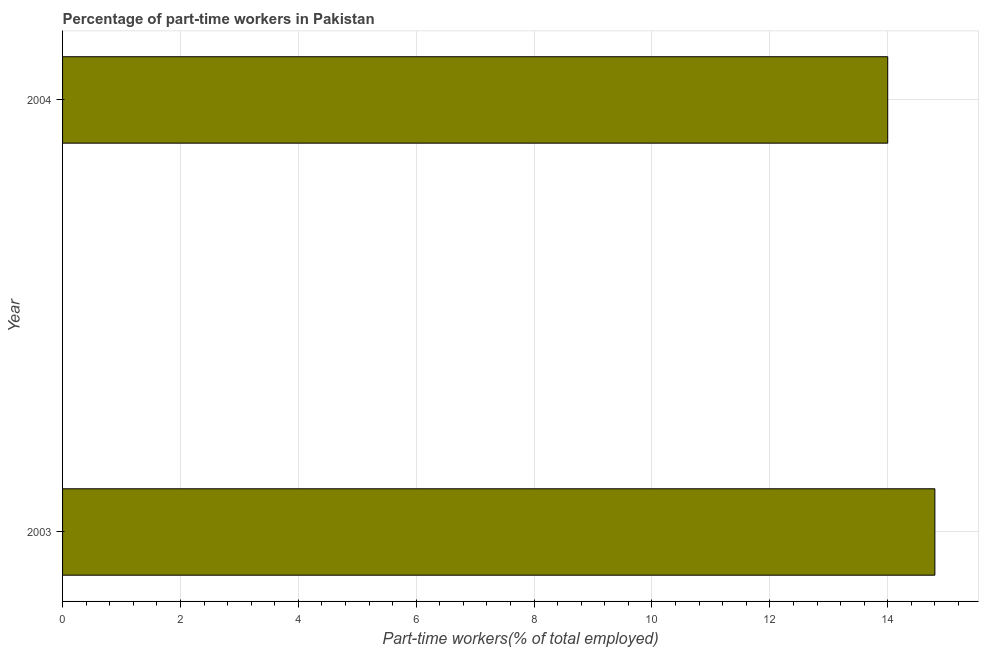Does the graph contain any zero values?
Offer a very short reply. No. Does the graph contain grids?
Your response must be concise. Yes. What is the title of the graph?
Provide a short and direct response. Percentage of part-time workers in Pakistan. What is the label or title of the X-axis?
Make the answer very short. Part-time workers(% of total employed). What is the label or title of the Y-axis?
Your answer should be compact. Year. What is the percentage of part-time workers in 2003?
Offer a terse response. 14.8. Across all years, what is the maximum percentage of part-time workers?
Offer a terse response. 14.8. Across all years, what is the minimum percentage of part-time workers?
Your answer should be very brief. 14. In which year was the percentage of part-time workers maximum?
Offer a terse response. 2003. In which year was the percentage of part-time workers minimum?
Offer a terse response. 2004. What is the sum of the percentage of part-time workers?
Keep it short and to the point. 28.8. What is the difference between the percentage of part-time workers in 2003 and 2004?
Give a very brief answer. 0.8. What is the average percentage of part-time workers per year?
Make the answer very short. 14.4. What is the median percentage of part-time workers?
Ensure brevity in your answer.  14.4. What is the ratio of the percentage of part-time workers in 2003 to that in 2004?
Your response must be concise. 1.06. How many bars are there?
Your response must be concise. 2. How many years are there in the graph?
Provide a succinct answer. 2. What is the difference between two consecutive major ticks on the X-axis?
Provide a succinct answer. 2. Are the values on the major ticks of X-axis written in scientific E-notation?
Offer a terse response. No. What is the Part-time workers(% of total employed) in 2003?
Give a very brief answer. 14.8. What is the difference between the Part-time workers(% of total employed) in 2003 and 2004?
Your answer should be very brief. 0.8. What is the ratio of the Part-time workers(% of total employed) in 2003 to that in 2004?
Provide a succinct answer. 1.06. 